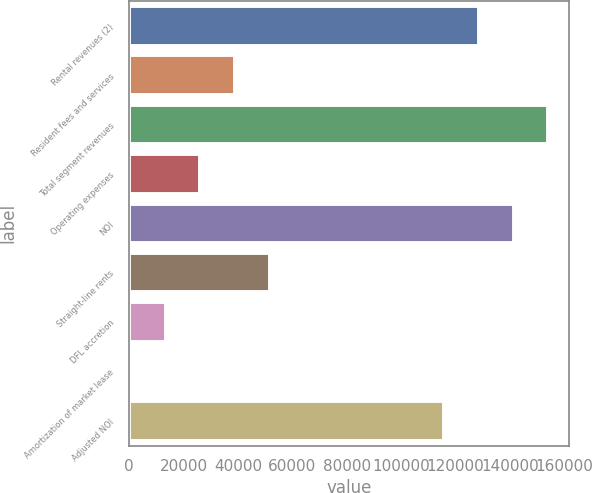<chart> <loc_0><loc_0><loc_500><loc_500><bar_chart><fcel>Rental revenues (2)<fcel>Resident fees and services<fcel>Total segment revenues<fcel>Operating expenses<fcel>NOI<fcel>Straight-line rents<fcel>DFL accretion<fcel>Amortization of market lease<fcel>Adjusted NOI<nl><fcel>128573<fcel>38895.9<fcel>154078<fcel>26143.6<fcel>141326<fcel>51648.2<fcel>13391.3<fcel>639<fcel>115821<nl></chart> 